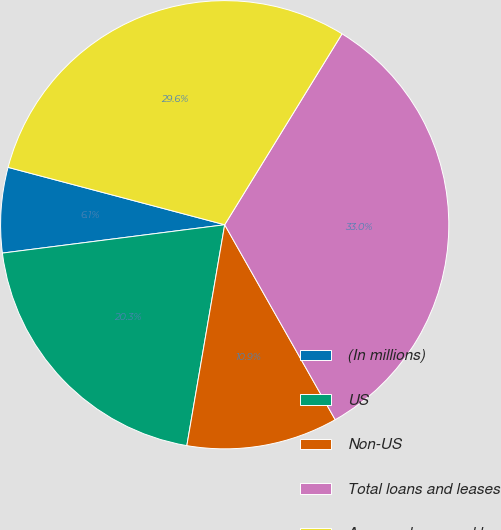Convert chart to OTSL. <chart><loc_0><loc_0><loc_500><loc_500><pie_chart><fcel>(In millions)<fcel>US<fcel>Non-US<fcel>Total loans and leases<fcel>Average loans and leases<nl><fcel>6.14%<fcel>20.28%<fcel>10.91%<fcel>33.02%<fcel>29.65%<nl></chart> 